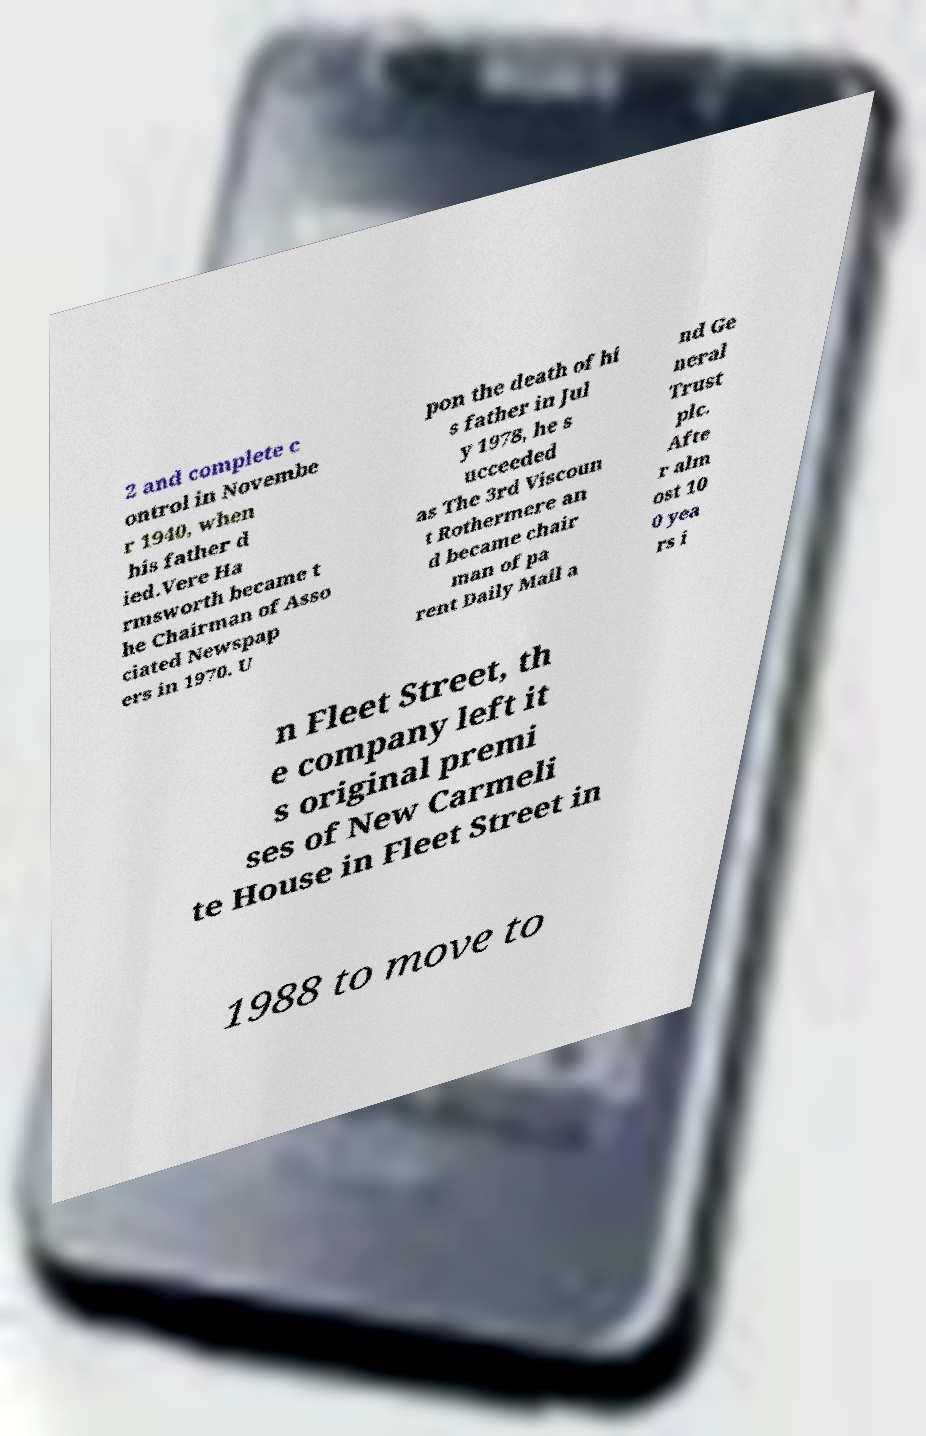Please read and relay the text visible in this image. What does it say? 2 and complete c ontrol in Novembe r 1940, when his father d ied.Vere Ha rmsworth became t he Chairman of Asso ciated Newspap ers in 1970. U pon the death of hi s father in Jul y 1978, he s ucceeded as The 3rd Viscoun t Rothermere an d became chair man of pa rent Daily Mail a nd Ge neral Trust plc. Afte r alm ost 10 0 yea rs i n Fleet Street, th e company left it s original premi ses of New Carmeli te House in Fleet Street in 1988 to move to 